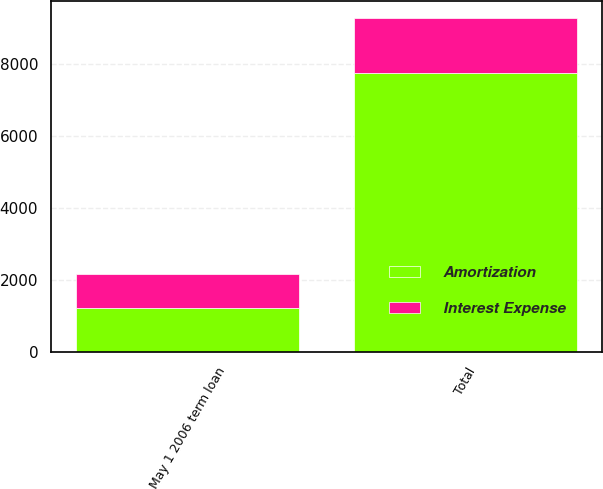<chart> <loc_0><loc_0><loc_500><loc_500><stacked_bar_chart><ecel><fcel>May 1 2006 term loan<fcel>Total<nl><fcel>Amortization<fcel>1219<fcel>7743<nl><fcel>Interest Expense<fcel>952<fcel>1525<nl></chart> 